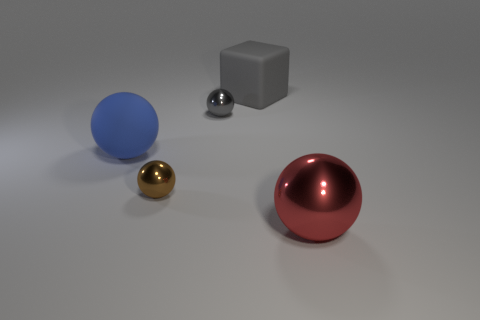How many matte things are either big red cylinders or tiny gray objects?
Keep it short and to the point. 0. There is a big object that is left of the brown metallic object; does it have the same shape as the big thing that is behind the matte ball?
Provide a succinct answer. No. There is a big thing that is both right of the gray ball and in front of the big gray rubber block; what is its color?
Offer a terse response. Red. There is a gray object in front of the large gray cube; is it the same size as the shiny ball that is to the left of the tiny gray sphere?
Offer a very short reply. Yes. What number of tiny shiny spheres are the same color as the rubber cube?
Your response must be concise. 1. How many small things are blue objects or gray spheres?
Give a very brief answer. 1. Are the big sphere that is behind the red shiny ball and the tiny gray sphere made of the same material?
Provide a succinct answer. No. The tiny ball that is right of the brown sphere is what color?
Ensure brevity in your answer.  Gray. Are there any blue things of the same size as the gray cube?
Make the answer very short. Yes. What material is the blue thing that is the same size as the gray matte block?
Keep it short and to the point. Rubber. 